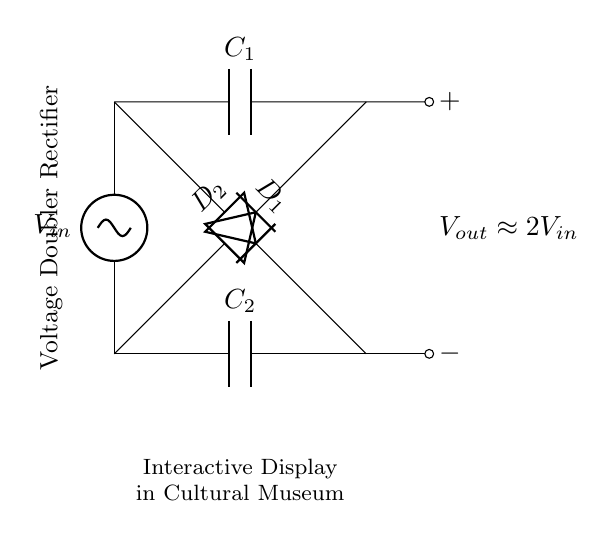What is the output voltage of this circuit? The output voltage is approximately double the input voltage, as indicated in the diagram.
Answer: approximately 2V_{in} How many capacitors are in this circuit? There are two capacitors present in the diagram, labeled C1 and C2.
Answer: 2 What type of circuit is represented? The diagram showcases a voltage doubler rectifier, as described in the title.
Answer: voltage doubler rectifier What are the diode labels in the circuit? The circuit contains two diodes labeled D1 and D2, which are essential for the rectification process.
Answer: D1 and D2 Explain the function of diodes in this circuit. Diodes allow current to flow in one direction only, which helps in converting AC input to a DC output, creating the voltage doubling effect.
Answer: rectify What happens to the input voltage when it passes through this circuit? The input voltage is effectively doubled at the output due to the configuration of the diodes and capacitors used in the circuit.
Answer: doubled 